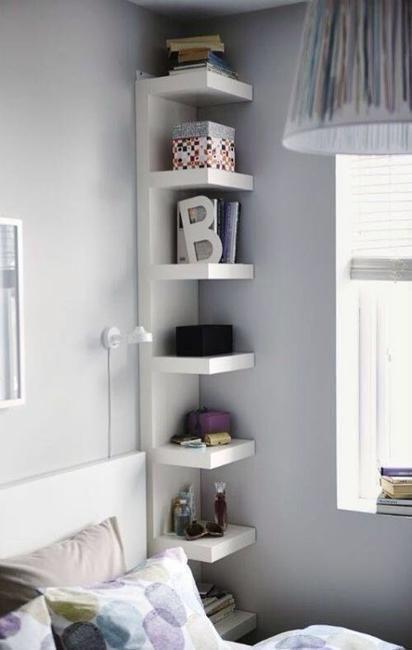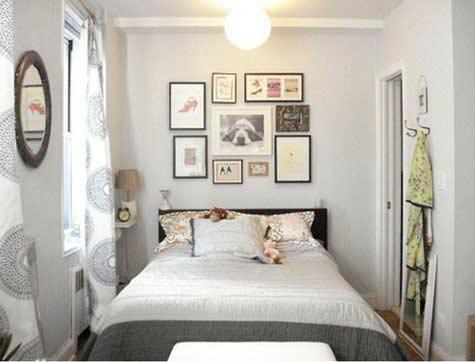The first image is the image on the left, the second image is the image on the right. Evaluate the accuracy of this statement regarding the images: "The left image includes a white corner shelf.". Is it true? Answer yes or no. Yes. 